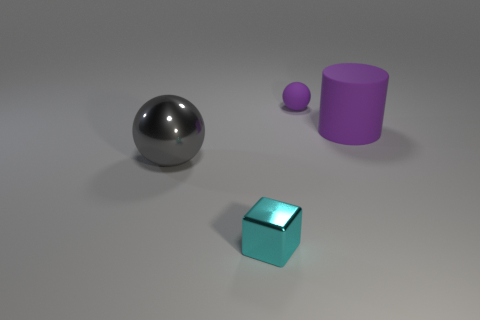Do the ball that is in front of the purple rubber sphere and the small object on the left side of the small rubber sphere have the same material?
Your answer should be compact. Yes. What is the material of the big thing that is the same shape as the tiny matte object?
Keep it short and to the point. Metal. Is the color of the sphere that is behind the purple matte cylinder the same as the big object that is right of the small cyan metallic object?
Offer a terse response. Yes. Is the number of large cylinders that are in front of the large sphere greater than the number of tiny gray metallic objects?
Keep it short and to the point. No. What shape is the small object that is behind the metal ball?
Offer a very short reply. Sphere. What number of other things are the same shape as the tiny cyan object?
Offer a terse response. 0. Is the tiny object that is in front of the tiny purple thing made of the same material as the tiny ball?
Keep it short and to the point. No. Is the number of gray objects behind the big gray metal sphere the same as the number of large cylinders that are to the left of the small cyan object?
Make the answer very short. Yes. What is the size of the metallic thing that is behind the tiny cyan block?
Keep it short and to the point. Large. Is there a cyan block that has the same material as the big gray sphere?
Give a very brief answer. Yes. 